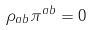Convert formula to latex. <formula><loc_0><loc_0><loc_500><loc_500>\rho _ { a b } \pi ^ { a b } = 0</formula> 